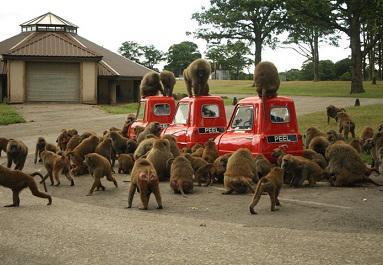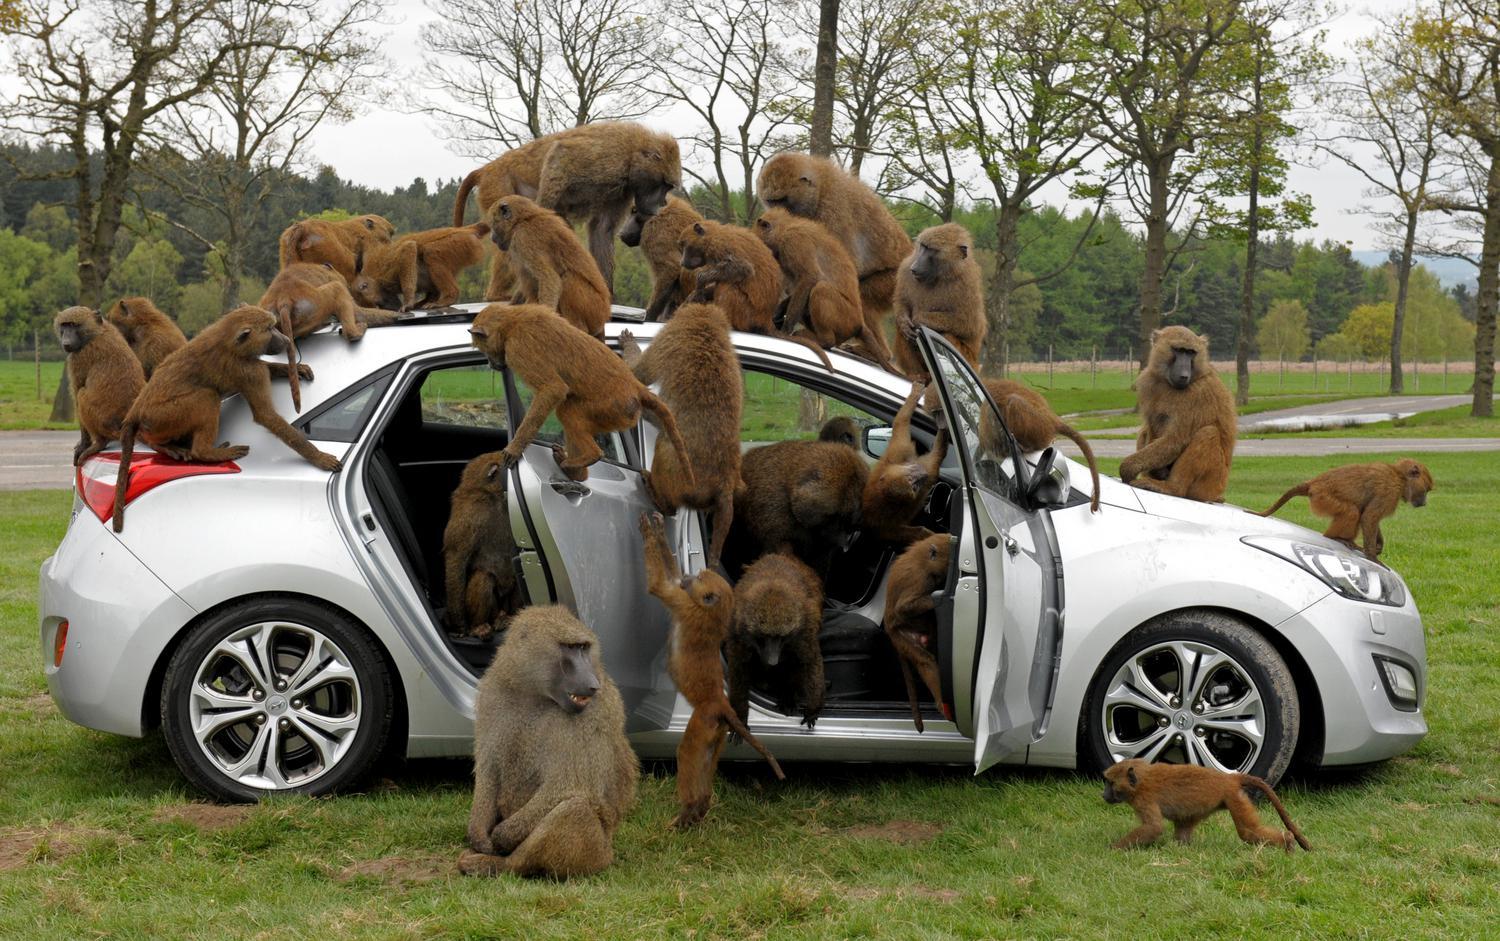The first image is the image on the left, the second image is the image on the right. For the images displayed, is the sentence "Several monkeys are sitting on top of a vehicle." factually correct? Answer yes or no. Yes. The first image is the image on the left, the second image is the image on the right. For the images shown, is this caption "In one image monkeys are interacting with a white vehicle with the doors open." true? Answer yes or no. Yes. 